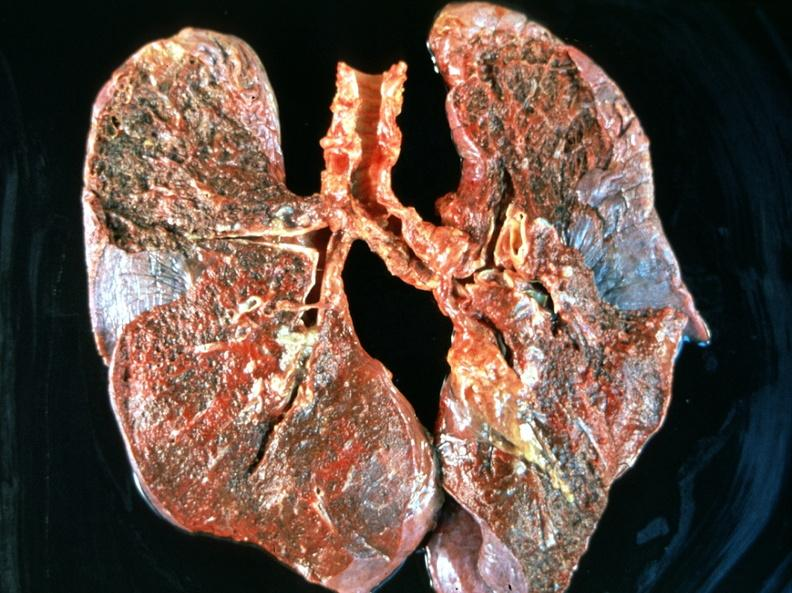s respiratory present?
Answer the question using a single word or phrase. Yes 